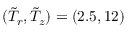Convert formula to latex. <formula><loc_0><loc_0><loc_500><loc_500>( \tilde { T } _ { r } , \tilde { T } _ { z } ) = ( 2 . 5 , 1 2 )</formula> 